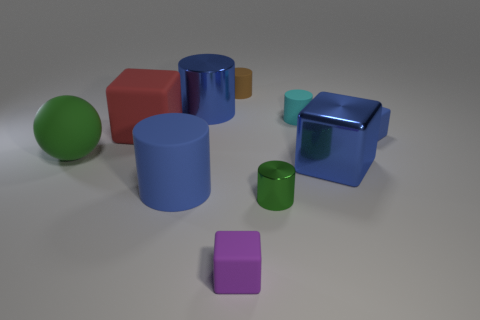Can you describe the colors and shapes of the objects in the image? Certainly! The image showcases objects of various shapes including cubes, cylinders, and a sphere. Their colors range from green, red, blue, to purple, and there's also a brown one. Each object has a distinct, smooth texture, and the lighting gives the scene a soft appearance. 